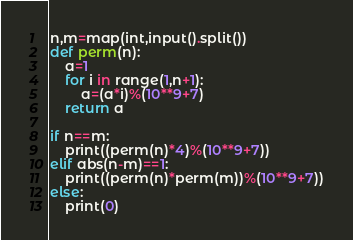<code> <loc_0><loc_0><loc_500><loc_500><_Python_>n,m=map(int,input().split())
def perm(n):
    a=1
    for i in range(1,n+1):
        a=(a*i)%(10**9+7)
    return a

if n==m:
    print((perm(n)*4)%(10**9+7))
elif abs(n-m)==1:
    print((perm(n)*perm(m))%(10**9+7))
else:
    print(0)
</code> 